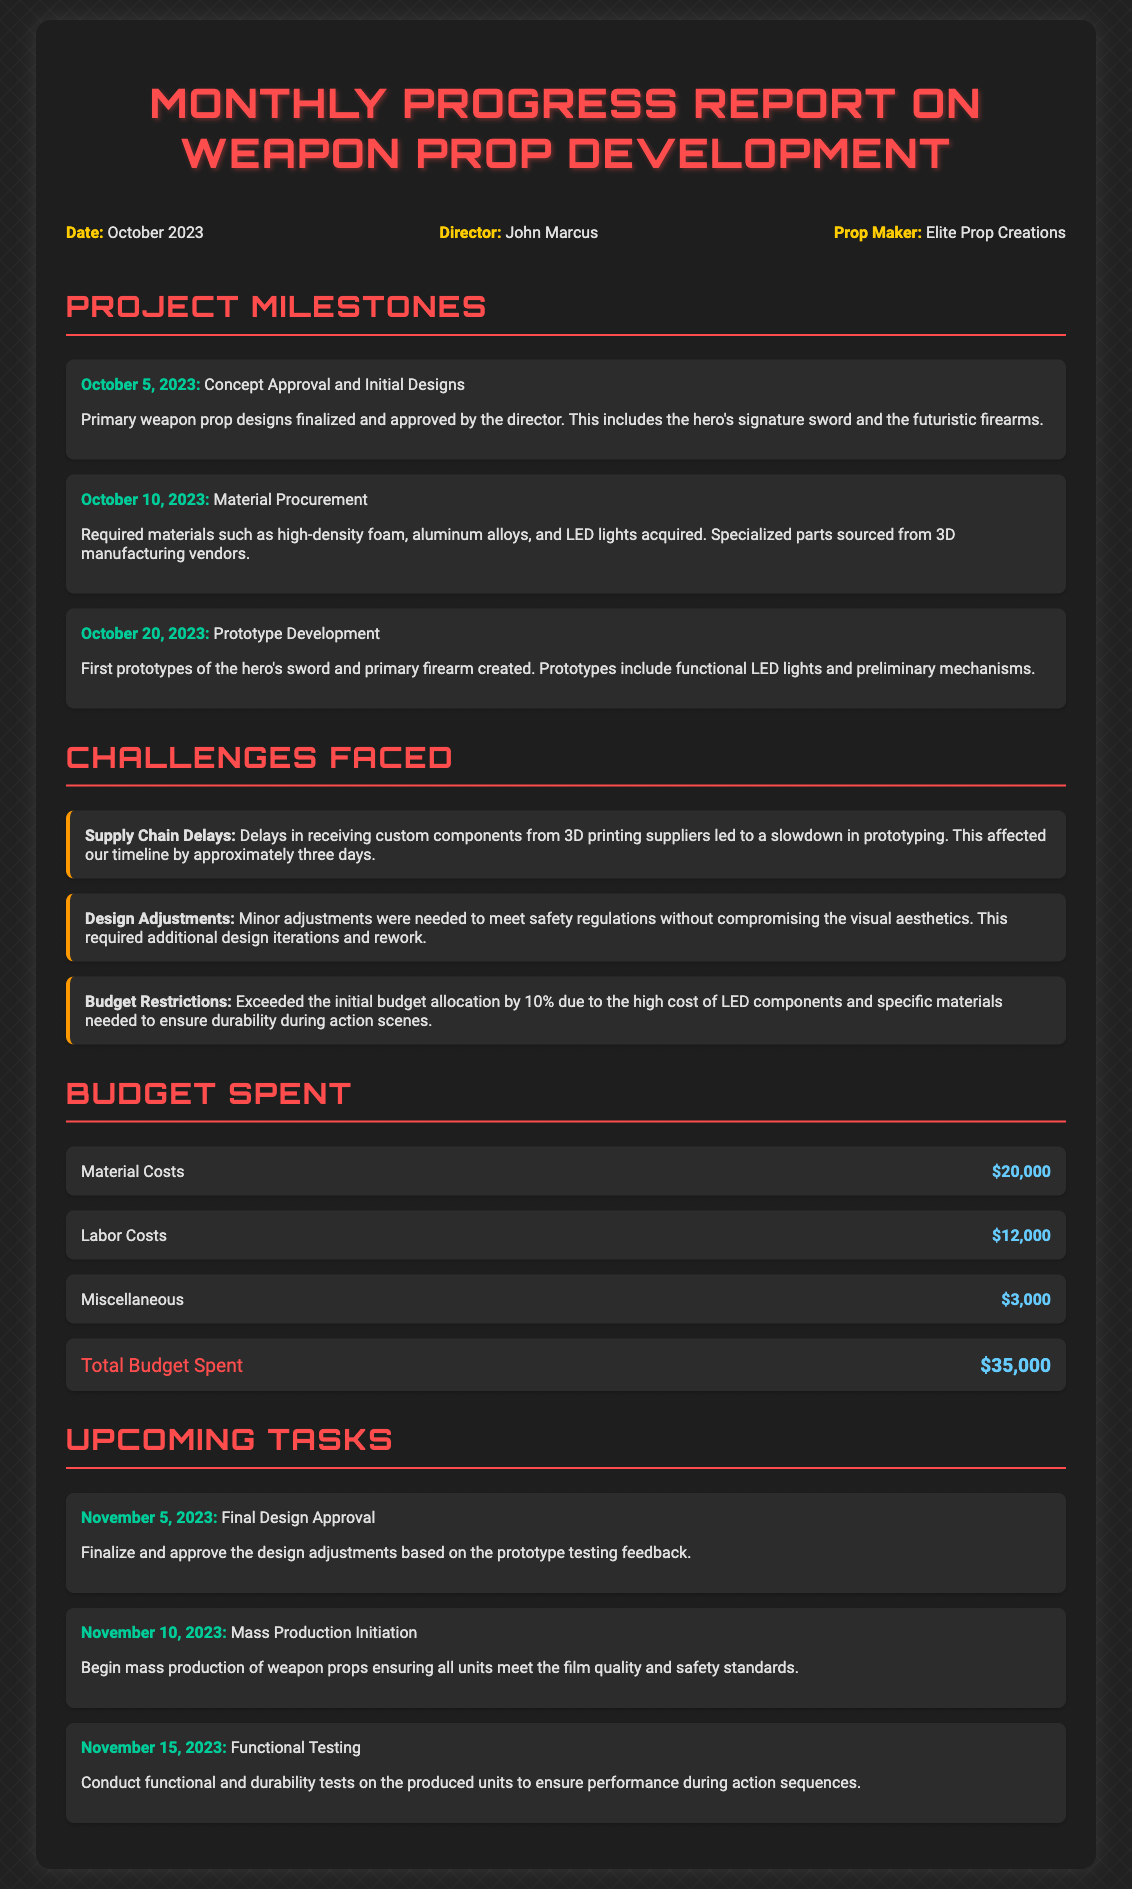What is the date of the report? The report is dated October 2023, as mentioned at the beginning of the document.
Answer: October 2023 Who is the director? The document states that the director is John Marcus.
Answer: John Marcus What was approved on October 5, 2023? The milestone on this date indicates that concept approval and initial designs were finalized.
Answer: Concept Approval and Initial Designs What is the total budget spent? The budget section lists a total of $35,000 spent on the project.
Answer: $35,000 What challenge was faced due to supply chain issues? The document indicates that supply chain delays affected prototyping timelines by about three days.
Answer: Supply Chain Delays When will mass production initiation begin? The timeline shows that mass production will begin on November 10, 2023.
Answer: November 10, 2023 What percentage did the budget exceed? The document mentions that the budget exceeded the initial allocation by 10%.
Answer: 10% How many tasks are listed under Upcoming Tasks? There are three tasks mentioned in the Upcoming Tasks section.
Answer: Three What materials were procured? The materials acquired included high-density foam, aluminum alloys, and LED lights, as listed in the document.
Answer: High-density foam, aluminum alloys, and LED lights 